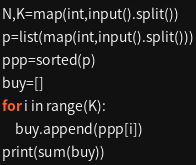<code> <loc_0><loc_0><loc_500><loc_500><_Python_>N,K=map(int,input().split())
p=list(map(int,input().split()))
ppp=sorted(p)
buy=[]
for i in range(K):
    buy.append(ppp[i])
print(sum(buy))</code> 